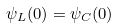<formula> <loc_0><loc_0><loc_500><loc_500>\psi _ { L } ( 0 ) = \psi _ { C } ( 0 )</formula> 